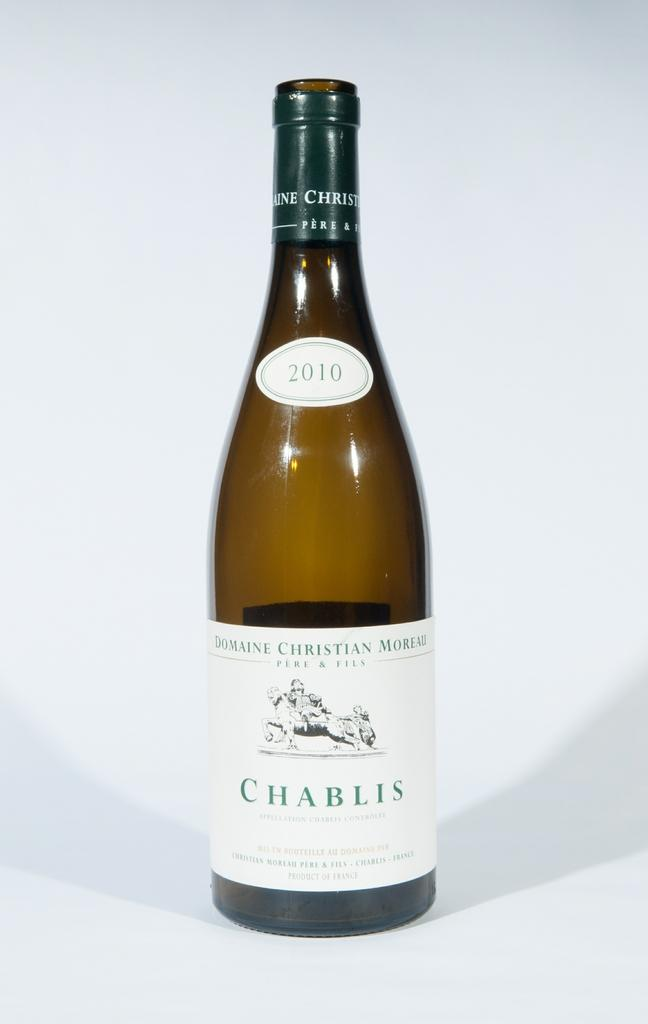<image>
Render a clear and concise summary of the photo. a bottle of 2010 chabils domaine christian moreau 